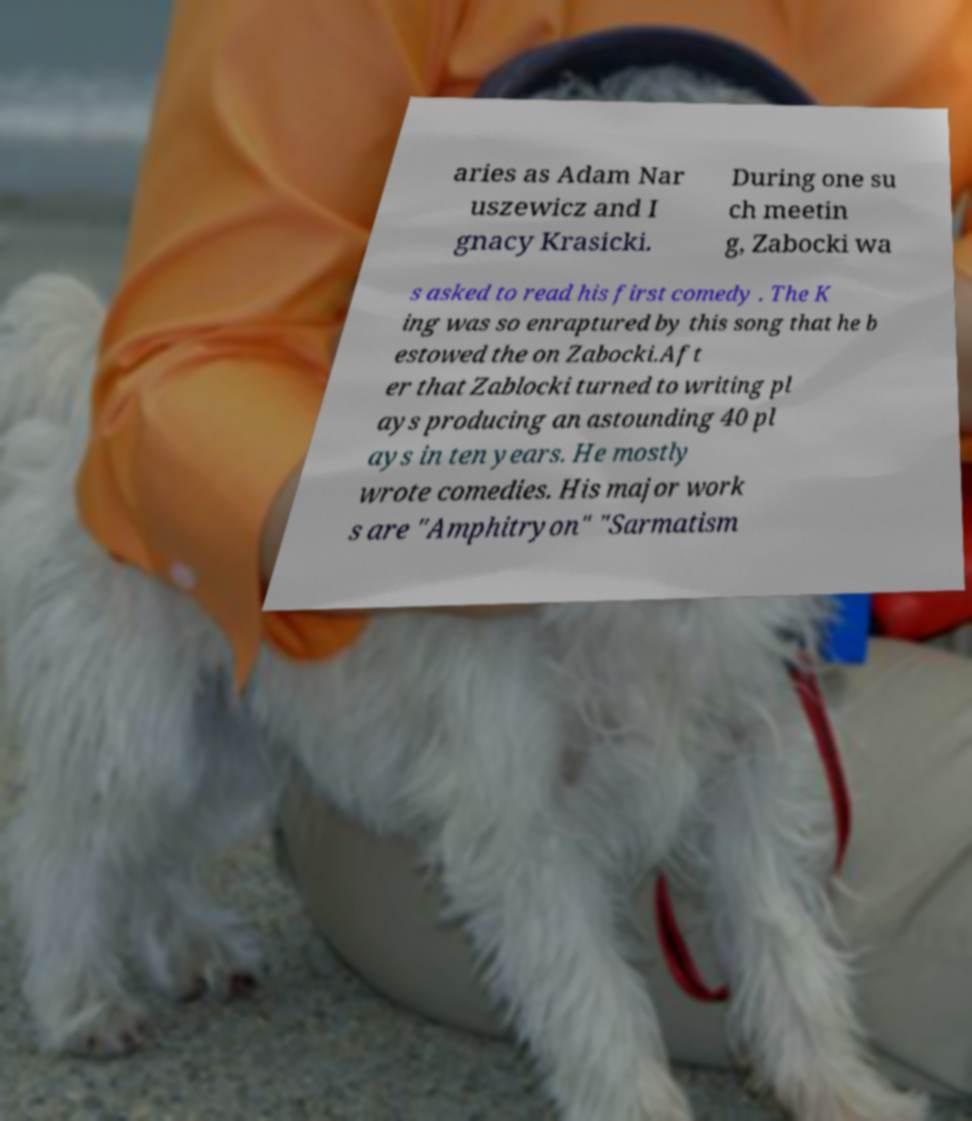Please identify and transcribe the text found in this image. aries as Adam Nar uszewicz and I gnacy Krasicki. During one su ch meetin g, Zabocki wa s asked to read his first comedy . The K ing was so enraptured by this song that he b estowed the on Zabocki.Aft er that Zablocki turned to writing pl ays producing an astounding 40 pl ays in ten years. He mostly wrote comedies. His major work s are "Amphitryon" "Sarmatism 